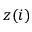<formula> <loc_0><loc_0><loc_500><loc_500>z ( i )</formula> 